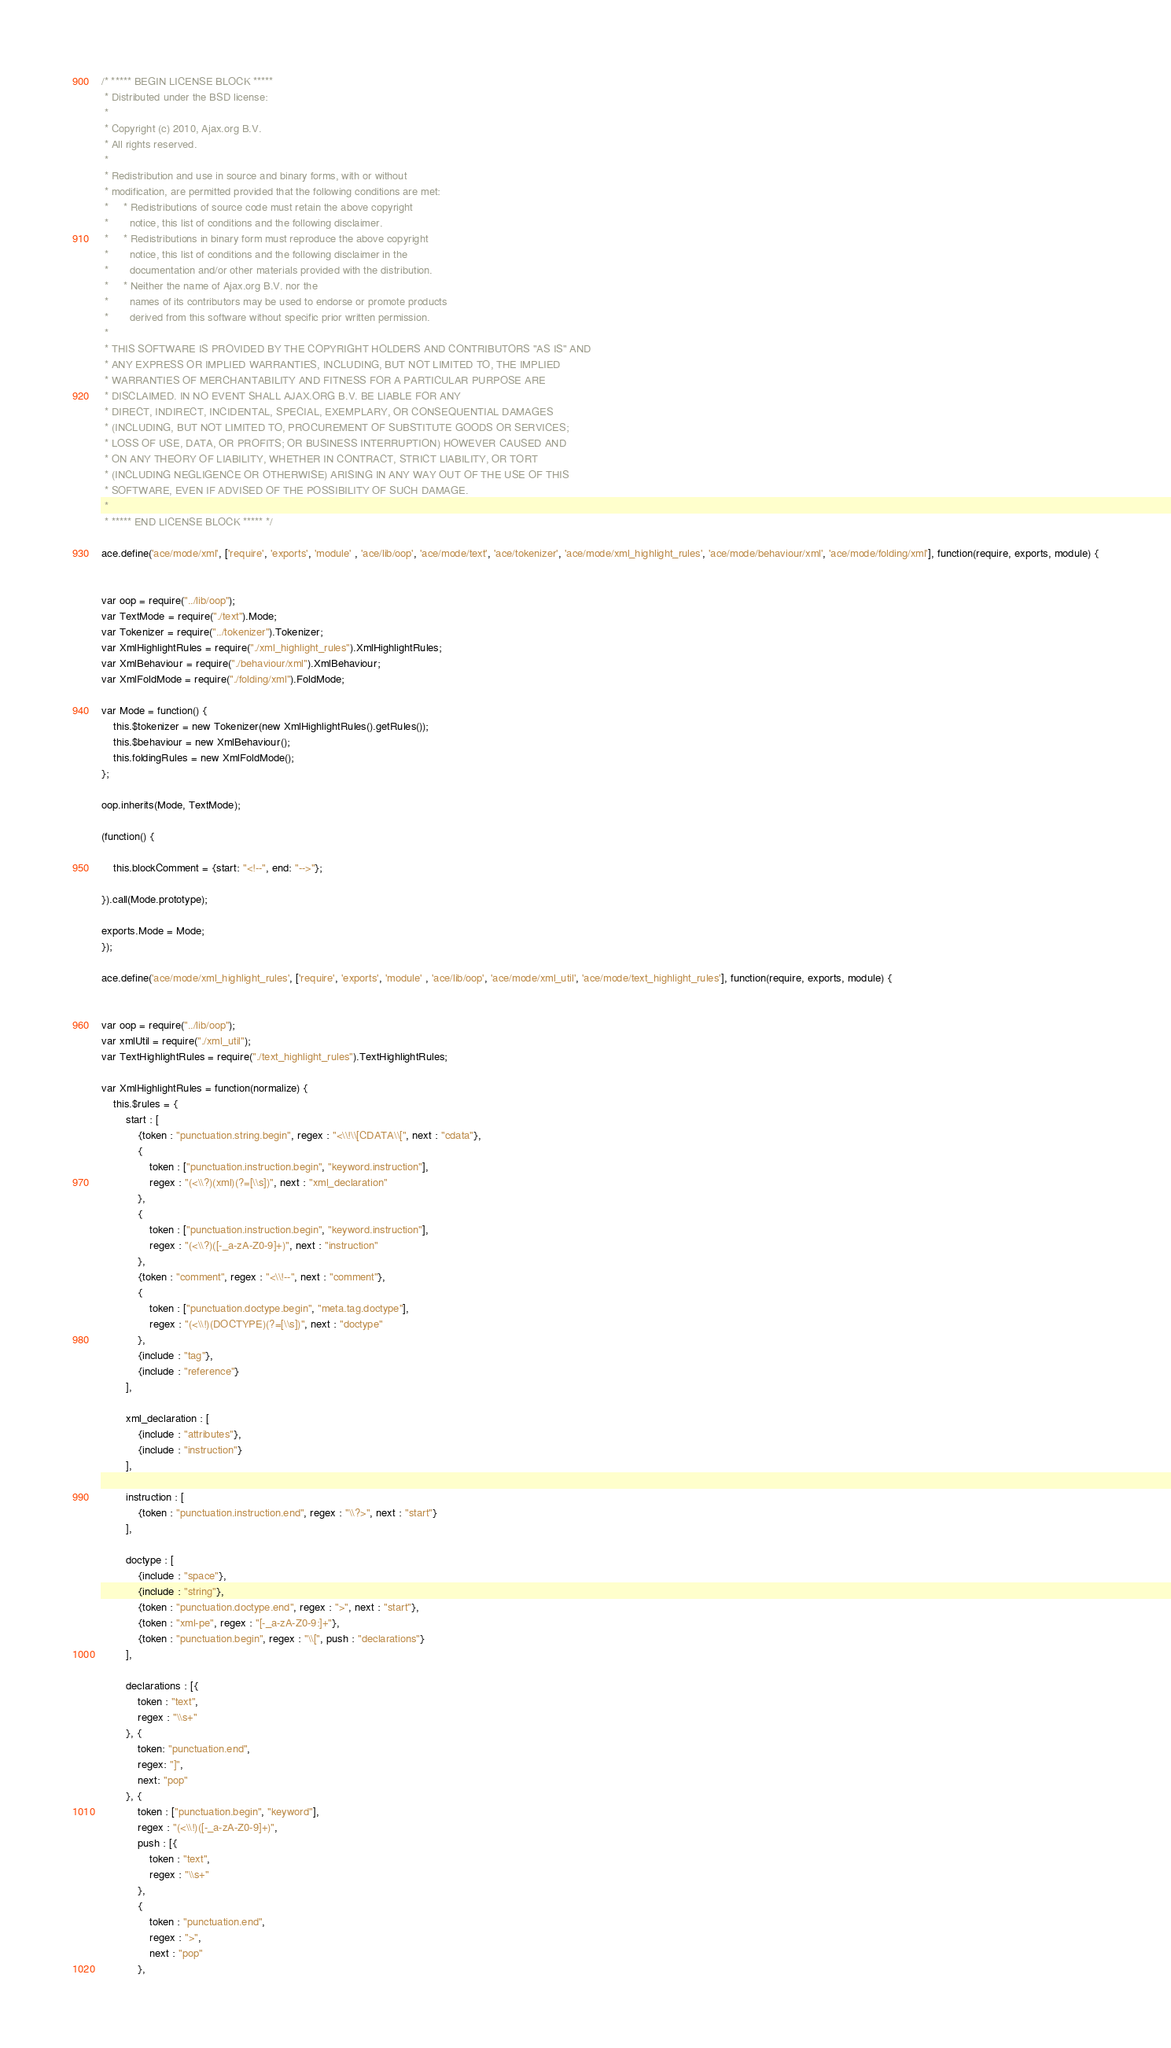<code> <loc_0><loc_0><loc_500><loc_500><_JavaScript_>/* ***** BEGIN LICENSE BLOCK *****
 * Distributed under the BSD license:
 *
 * Copyright (c) 2010, Ajax.org B.V.
 * All rights reserved.
 * 
 * Redistribution and use in source and binary forms, with or without
 * modification, are permitted provided that the following conditions are met:
 *     * Redistributions of source code must retain the above copyright
 *       notice, this list of conditions and the following disclaimer.
 *     * Redistributions in binary form must reproduce the above copyright
 *       notice, this list of conditions and the following disclaimer in the
 *       documentation and/or other materials provided with the distribution.
 *     * Neither the name of Ajax.org B.V. nor the
 *       names of its contributors may be used to endorse or promote products
 *       derived from this software without specific prior written permission.
 * 
 * THIS SOFTWARE IS PROVIDED BY THE COPYRIGHT HOLDERS AND CONTRIBUTORS "AS IS" AND
 * ANY EXPRESS OR IMPLIED WARRANTIES, INCLUDING, BUT NOT LIMITED TO, THE IMPLIED
 * WARRANTIES OF MERCHANTABILITY AND FITNESS FOR A PARTICULAR PURPOSE ARE
 * DISCLAIMED. IN NO EVENT SHALL AJAX.ORG B.V. BE LIABLE FOR ANY
 * DIRECT, INDIRECT, INCIDENTAL, SPECIAL, EXEMPLARY, OR CONSEQUENTIAL DAMAGES
 * (INCLUDING, BUT NOT LIMITED TO, PROCUREMENT OF SUBSTITUTE GOODS OR SERVICES;
 * LOSS OF USE, DATA, OR PROFITS; OR BUSINESS INTERRUPTION) HOWEVER CAUSED AND
 * ON ANY THEORY OF LIABILITY, WHETHER IN CONTRACT, STRICT LIABILITY, OR TORT
 * (INCLUDING NEGLIGENCE OR OTHERWISE) ARISING IN ANY WAY OUT OF THE USE OF THIS
 * SOFTWARE, EVEN IF ADVISED OF THE POSSIBILITY OF SUCH DAMAGE.
 *
 * ***** END LICENSE BLOCK ***** */

ace.define('ace/mode/xml', ['require', 'exports', 'module' , 'ace/lib/oop', 'ace/mode/text', 'ace/tokenizer', 'ace/mode/xml_highlight_rules', 'ace/mode/behaviour/xml', 'ace/mode/folding/xml'], function(require, exports, module) {


var oop = require("../lib/oop");
var TextMode = require("./text").Mode;
var Tokenizer = require("../tokenizer").Tokenizer;
var XmlHighlightRules = require("./xml_highlight_rules").XmlHighlightRules;
var XmlBehaviour = require("./behaviour/xml").XmlBehaviour;
var XmlFoldMode = require("./folding/xml").FoldMode;

var Mode = function() {
    this.$tokenizer = new Tokenizer(new XmlHighlightRules().getRules());
    this.$behaviour = new XmlBehaviour();
    this.foldingRules = new XmlFoldMode();
};

oop.inherits(Mode, TextMode);

(function() {
    
    this.blockComment = {start: "<!--", end: "-->"};

}).call(Mode.prototype);

exports.Mode = Mode;
});

ace.define('ace/mode/xml_highlight_rules', ['require', 'exports', 'module' , 'ace/lib/oop', 'ace/mode/xml_util', 'ace/mode/text_highlight_rules'], function(require, exports, module) {


var oop = require("../lib/oop");
var xmlUtil = require("./xml_util");
var TextHighlightRules = require("./text_highlight_rules").TextHighlightRules;

var XmlHighlightRules = function(normalize) {
    this.$rules = {
        start : [
            {token : "punctuation.string.begin", regex : "<\\!\\[CDATA\\[", next : "cdata"},
            {
                token : ["punctuation.instruction.begin", "keyword.instruction"],
                regex : "(<\\?)(xml)(?=[\\s])", next : "xml_declaration"
            },
            {
                token : ["punctuation.instruction.begin", "keyword.instruction"],
                regex : "(<\\?)([-_a-zA-Z0-9]+)", next : "instruction"
            },
            {token : "comment", regex : "<\\!--", next : "comment"},
            {
                token : ["punctuation.doctype.begin", "meta.tag.doctype"],
                regex : "(<\\!)(DOCTYPE)(?=[\\s])", next : "doctype"
            },
            {include : "tag"},
            {include : "reference"}
        ],

        xml_declaration : [
            {include : "attributes"},
            {include : "instruction"}
        ],

        instruction : [
            {token : "punctuation.instruction.end", regex : "\\?>", next : "start"}
        ],

        doctype : [
            {include : "space"},
            {include : "string"},
            {token : "punctuation.doctype.end", regex : ">", next : "start"},
            {token : "xml-pe", regex : "[-_a-zA-Z0-9:]+"},
            {token : "punctuation.begin", regex : "\\[", push : "declarations"}
        ],

        declarations : [{
            token : "text",
            regex : "\\s+"
        }, {
            token: "punctuation.end",
            regex: "]",
            next: "pop"
        }, {
            token : ["punctuation.begin", "keyword"],
            regex : "(<\\!)([-_a-zA-Z0-9]+)",
            push : [{
                token : "text",
                regex : "\\s+"
            },
            {
                token : "punctuation.end",
                regex : ">",
                next : "pop"
            },</code> 